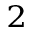Convert formula to latex. <formula><loc_0><loc_0><loc_500><loc_500>^ { 2 }</formula> 